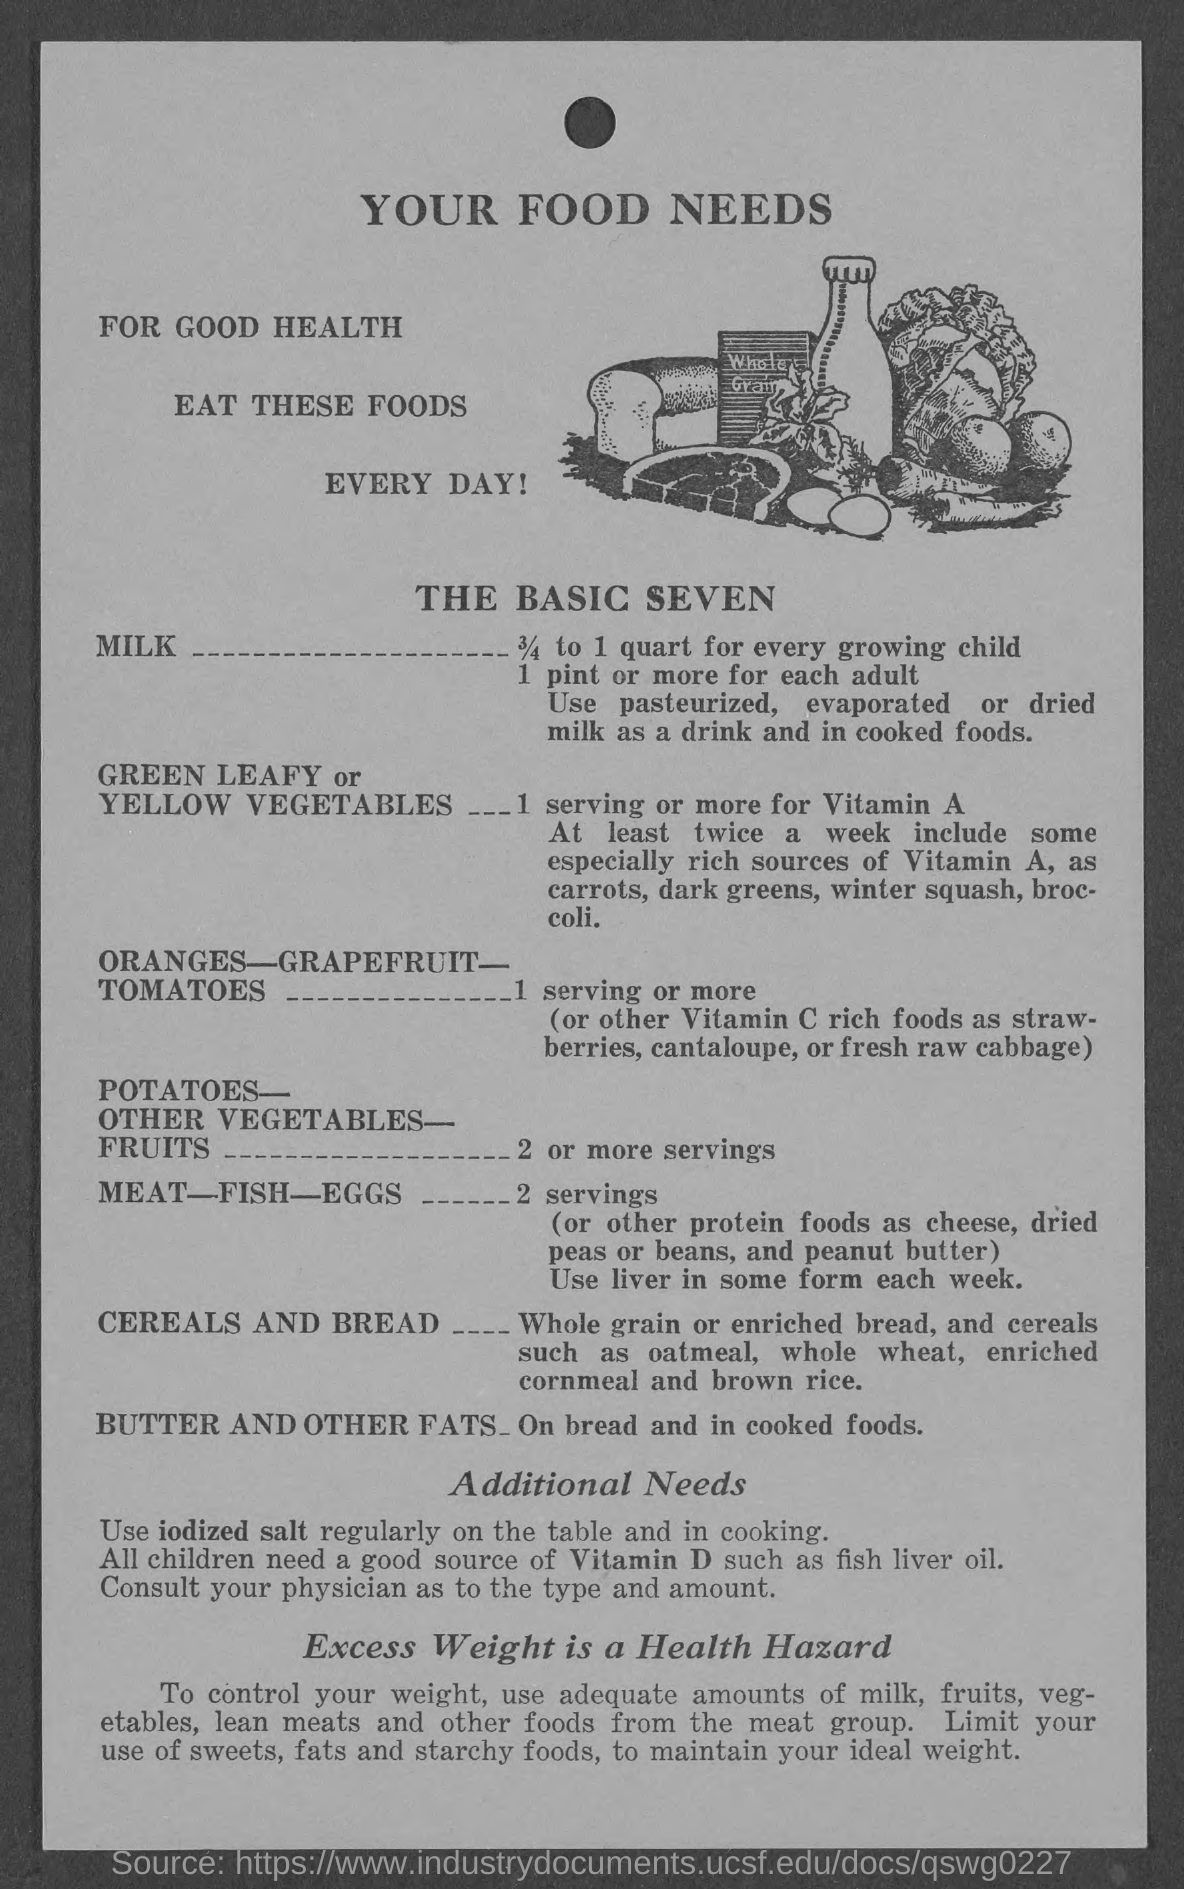Indicate a few pertinent items in this graphic. The title of the document is "What is the Title of the document? Your food needs...". The recommended amount of milk for growing children is 3/4 to 1 quart per day. 